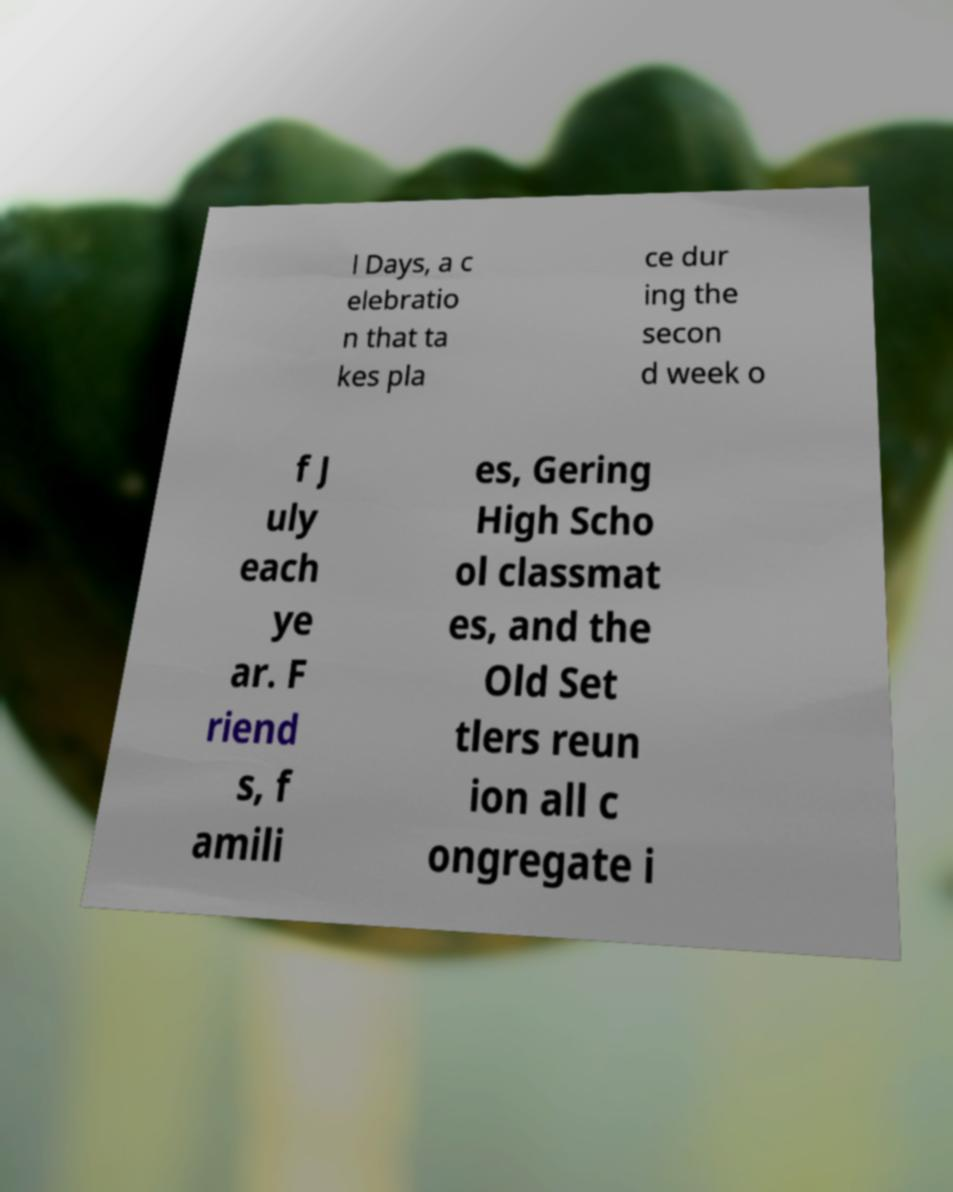Can you accurately transcribe the text from the provided image for me? l Days, a c elebratio n that ta kes pla ce dur ing the secon d week o f J uly each ye ar. F riend s, f amili es, Gering High Scho ol classmat es, and the Old Set tlers reun ion all c ongregate i 